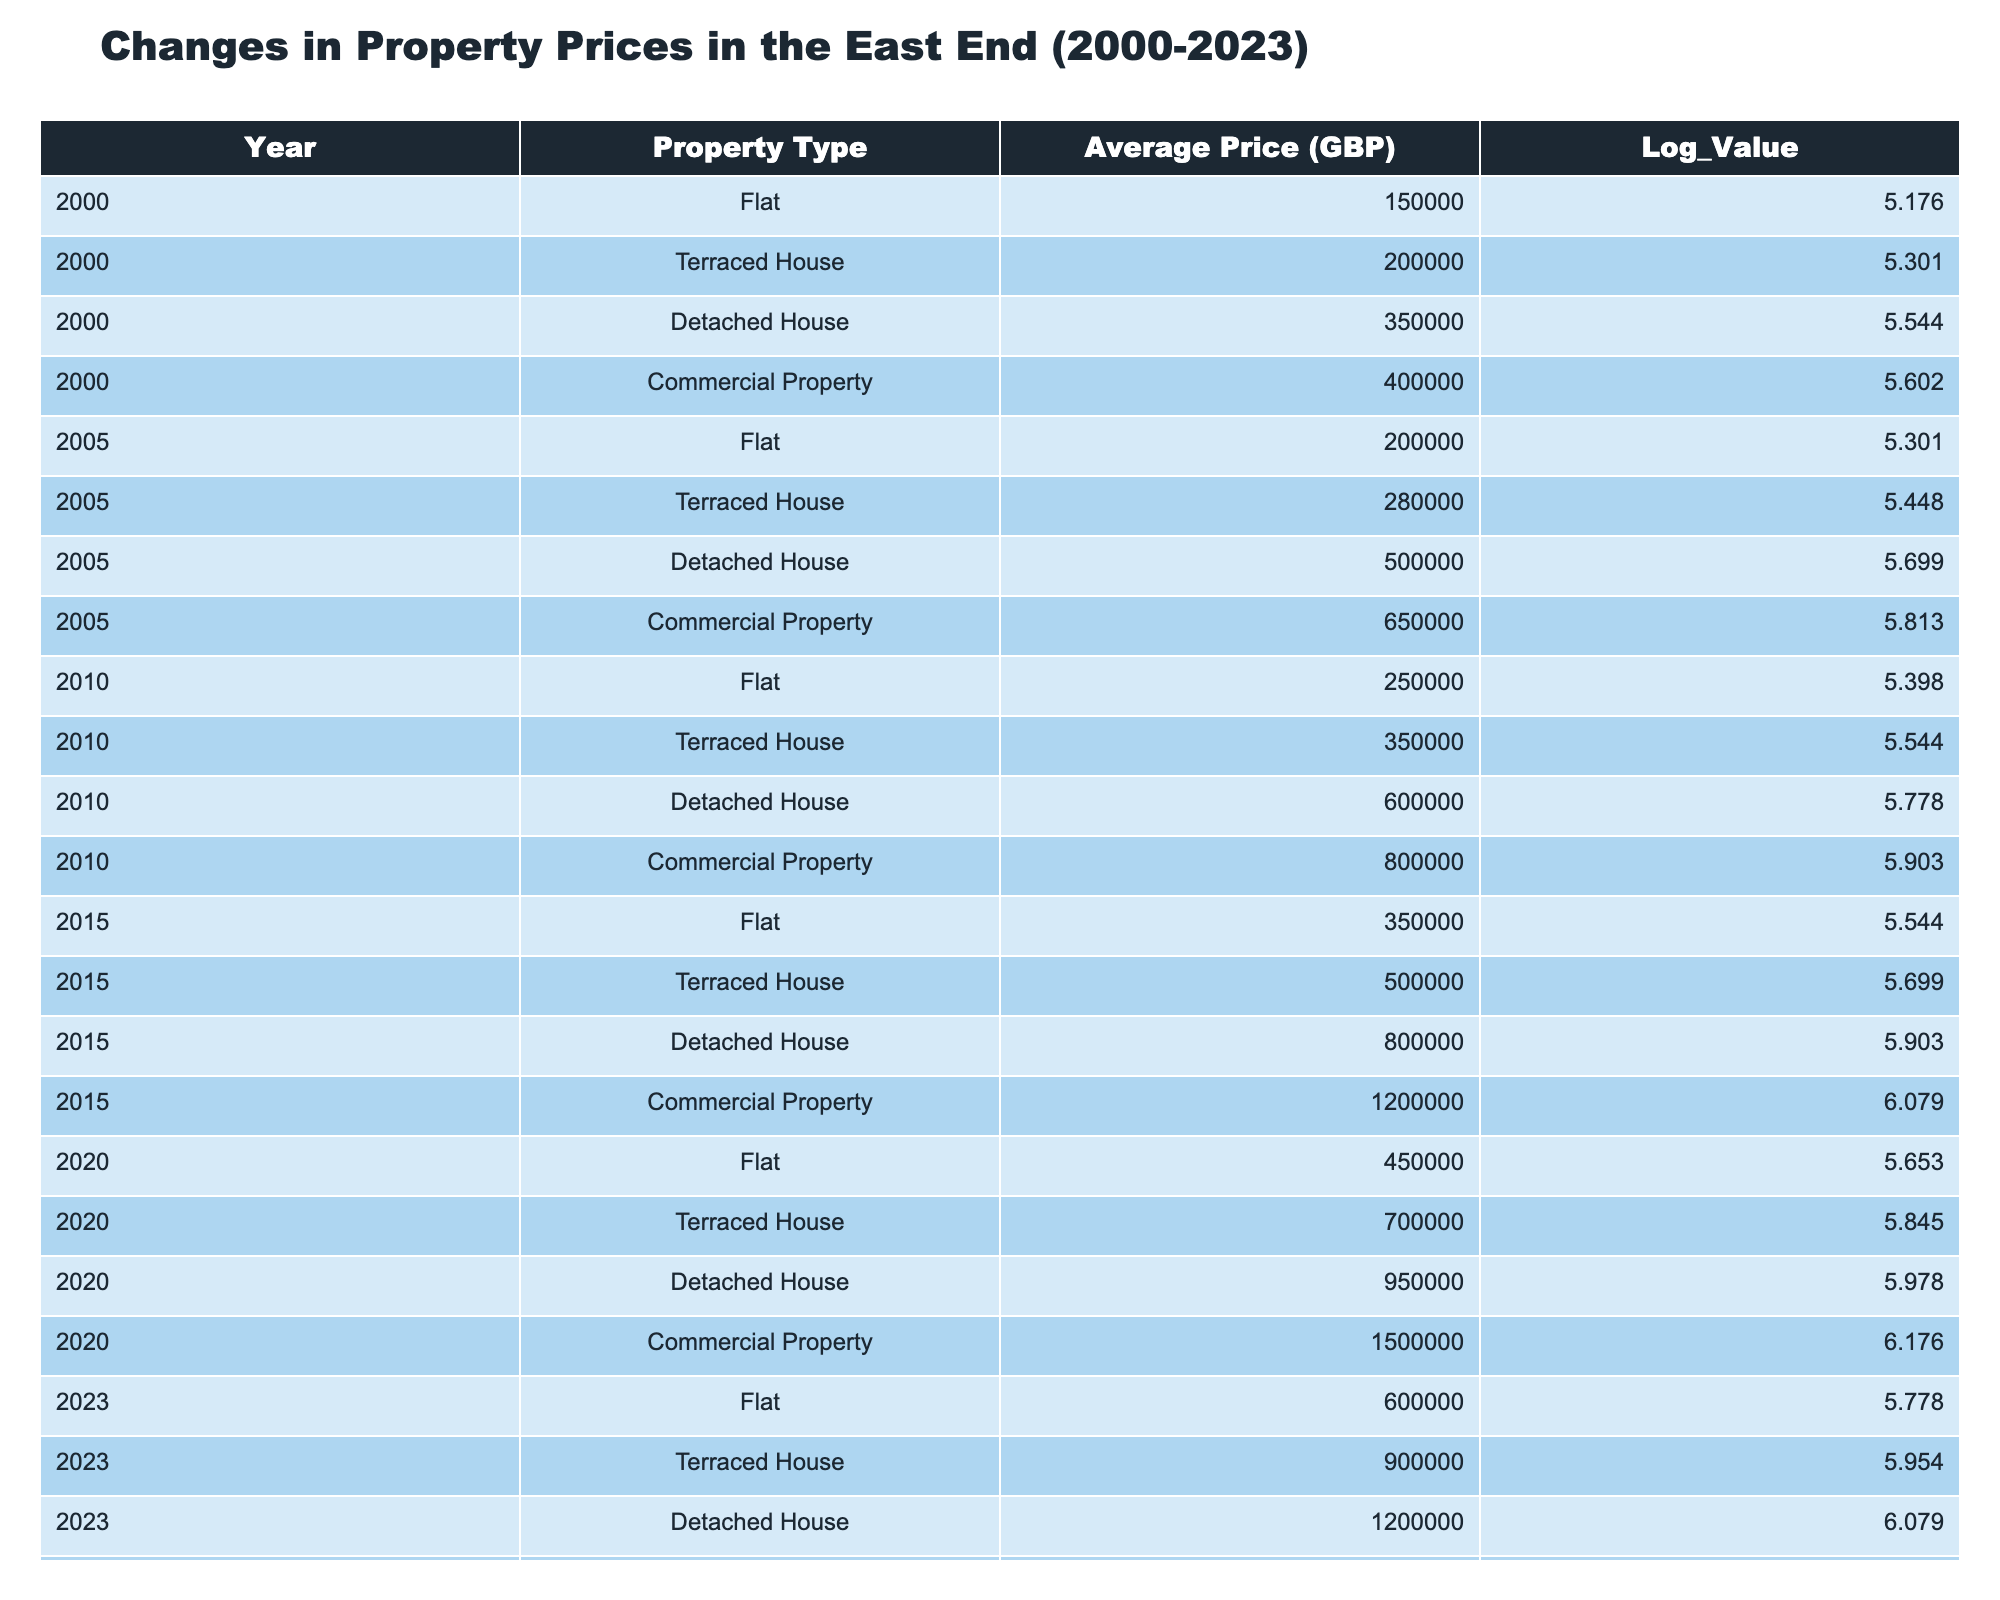What was the average price of a Detached House in 2010? In 2010, the average price of a Detached House was listed in the table as 600000 GBP.
Answer: 600000 GBP What was the average price of Flats in 2020 and 2023? The average price of Flats in 2020 was 450000 GBP and in 2023 was 600000 GBP. To find the average for these two years, we add them (450000 + 600000 = 1050000) and divide by 2 (1050000 / 2 = 525000).
Answer: 525000 GBP Is the average price of a Terraced House in 2023 higher than in 2020? The average price of a Terraced House in 2023 is 900000 GBP, while in 2020 it was 700000 GBP. Since 900000 is greater than 700000, the statement is true.
Answer: Yes What was the percentage increase in the average price of Commercial Property from 2000 to 2023? In 2000, the average price of Commercial Property was 400000 GBP, and in 2023 it was 1800000 GBP. The increase is calculated by (1800000 - 400000) / 400000 * 100 = 350%.
Answer: 350% Which property type had the highest average price in 2015, and what was that price? In 2015, the Detached House had the highest average price of 800000 GBP, compared to other types that were lower (Flat at 350000 GBP, Terraced House at 500000 GBP, and Commercial Property at 1200000 GBP).
Answer: Detached House, 800000 GBP How much higher was the average price of Detached Houses in 2023 compared to 2005? The average price of Detached Houses in 2023 was 1200000 GBP and in 2005 it was 500000 GBP. The difference is 1200000 - 500000 = 700000 GBP.
Answer: 700000 GBP In which year was the average price of a Flat the lowest, and what was that price? The average price of a Flat was lowest in 2000 at 150000 GBP, which can be observed from the data.
Answer: 2000, 150000 GBP What is the average price of Commercial Properties from 2000 to 2020? The average prices for Commercial Properties are 400000 GBP in 2000, 650000 GBP in 2005, 800000 GBP in 2010, 1200000 GBP in 2015, and 1500000 GBP in 2020. The total is 400000 + 650000 + 800000 + 1200000 + 1500000 = 3850000. Dividing by 5 gives an average of 770000 GBP.
Answer: 770000 GBP 